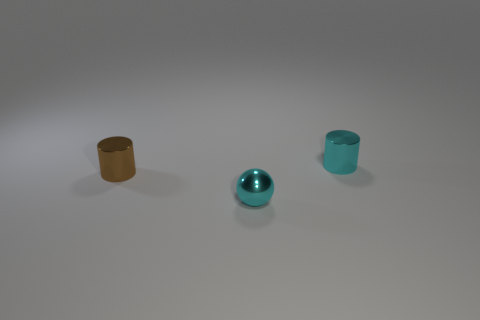Add 1 small cyan metallic things. How many objects exist? 4 Subtract all cylinders. How many objects are left? 1 Subtract all brown cylinders. How many cylinders are left? 1 Subtract 0 gray cylinders. How many objects are left? 3 Subtract all purple balls. Subtract all green cylinders. How many balls are left? 1 Subtract all large cyan cylinders. Subtract all tiny brown shiny things. How many objects are left? 2 Add 2 small cylinders. How many small cylinders are left? 4 Add 1 large red blocks. How many large red blocks exist? 1 